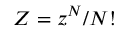<formula> <loc_0><loc_0><loc_500><loc_500>Z = z ^ { N } / N !</formula> 